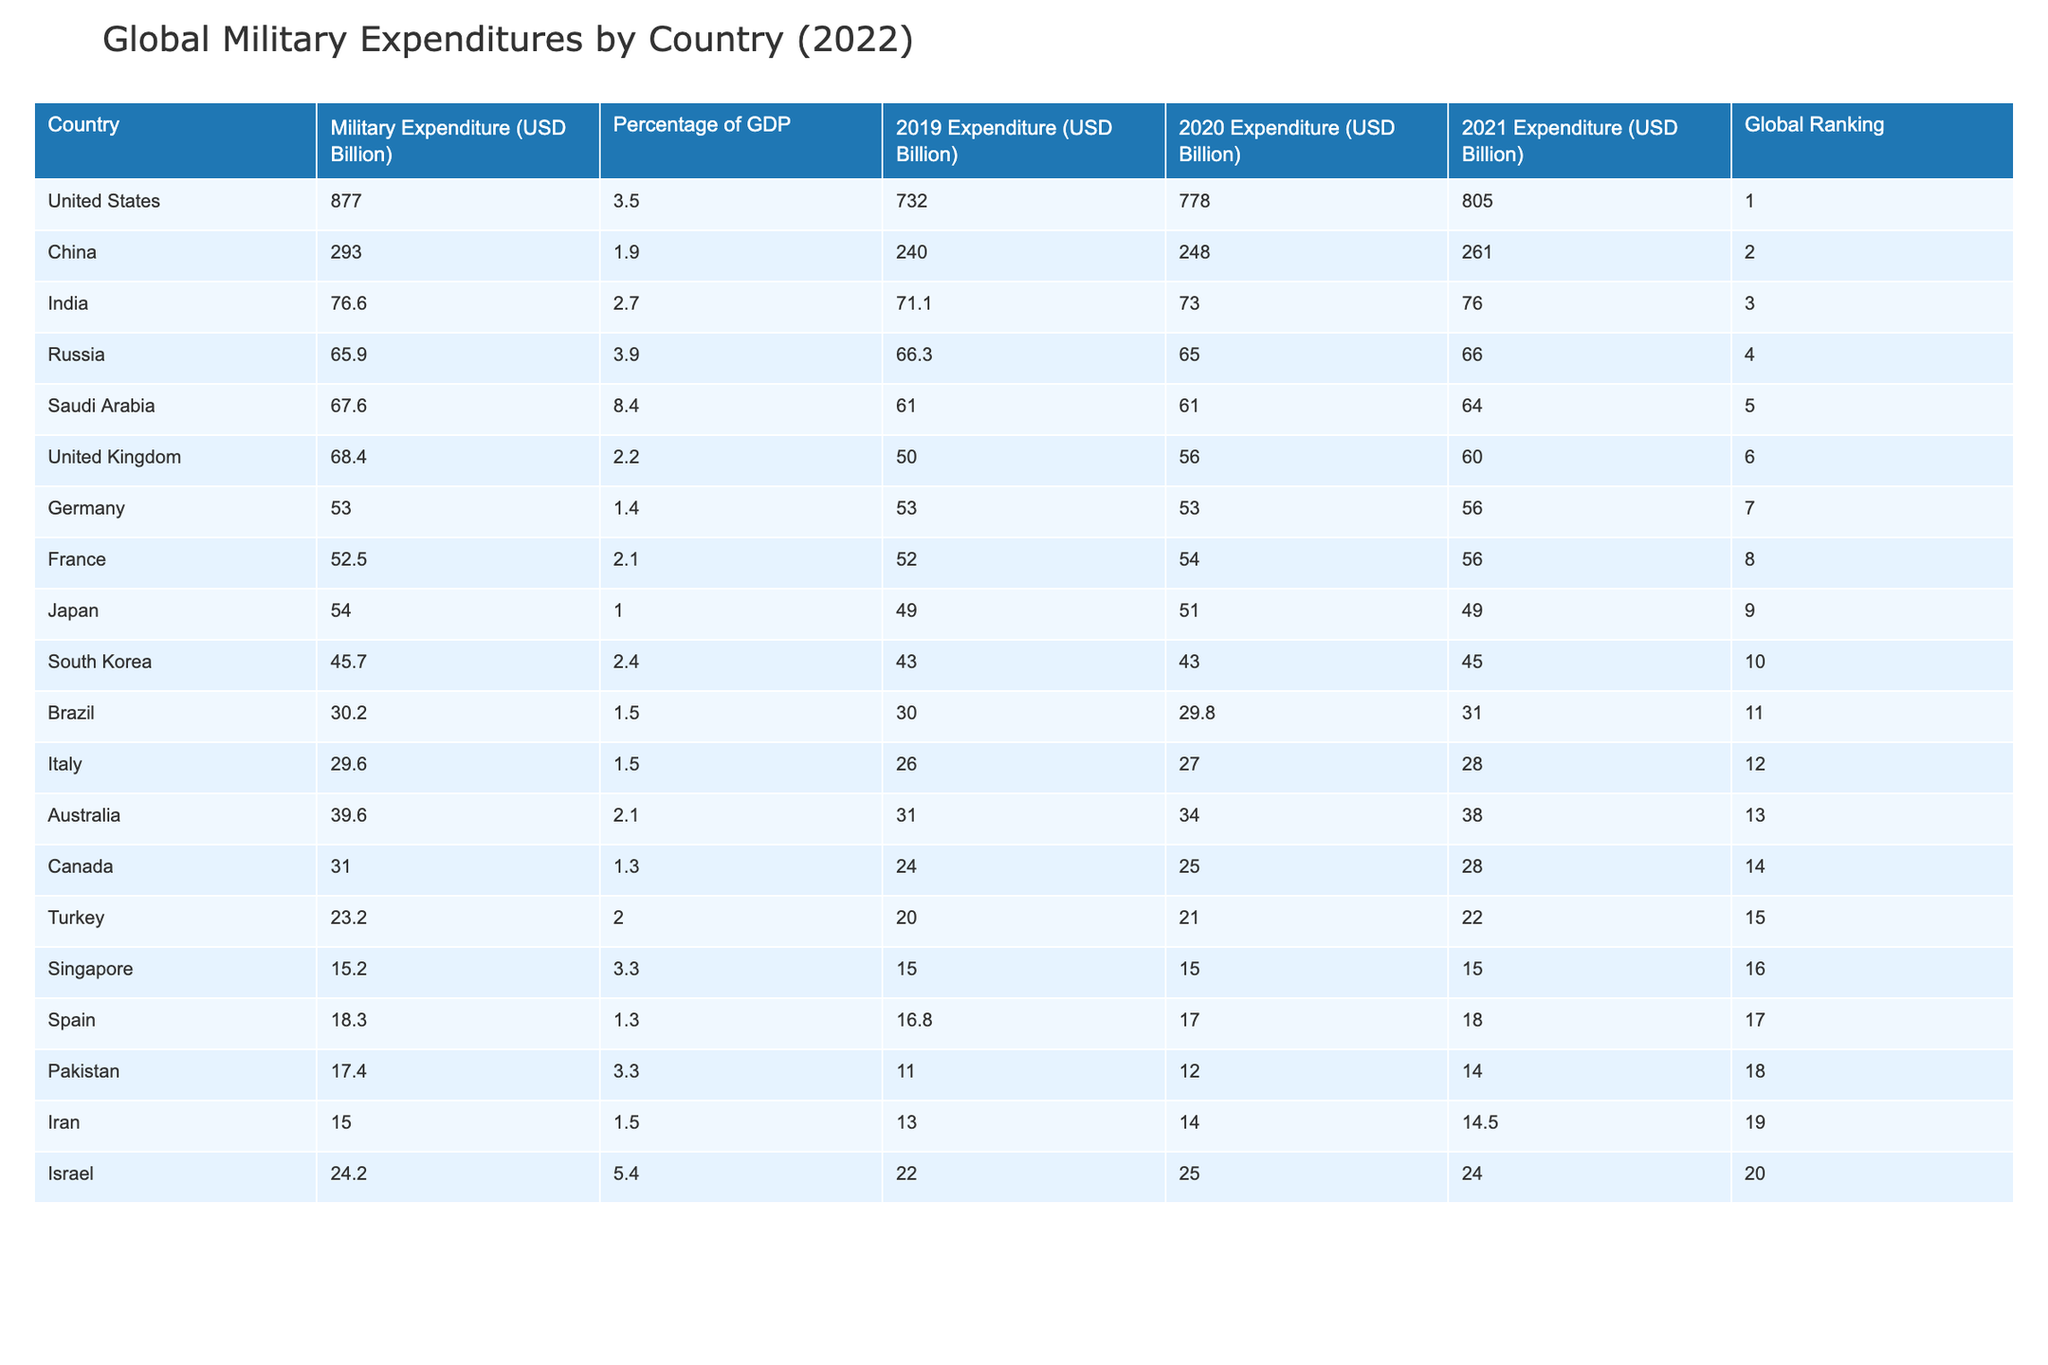What was the military expenditure of China in 2022? The table shows that China's military expenditure in 2022 was 293.0 billion USD, which is located in the column labeled 'Military Expenditure (USD Billion)' under the row for China.
Answer: 293.0 billion USD Which country spent the least on military expenditures in 2022? By comparing the military expenditures listed for each country, Pakistan has the lowest expenditure at 17.4 billion USD. This is found in the 'Military Expenditure (USD Billion)' column.
Answer: Pakistan What is the difference in military expenditure between the United States and India in 2022? The military expenditure for the United States is 877.0 billion USD and for India it is 76.6 billion USD. The difference is calculated as 877.0 - 76.6 = 800.4 billion USD.
Answer: 800.4 billion USD Is France's military expenditure higher than Japan's in 2022? France's military expenditure in 2022 is 52.5 billion USD while Japan's is 54.0 billion USD. By comparing these two values, it is clear that 52.5 is less than 54.0, therefore, the statement is false.
Answer: No What is the average military expenditure of the top 5 military spenders in 2022? The top 5 countries are the United States, China, India, Russia, and Saudi Arabia with expenditures of 877.0, 293.0, 76.6, 65.9, and 67.6 billion USD respectively. The total expenditure is 877.0 + 293.0 + 76.6 + 65.9 + 67.6 = 1380.1 billion USD. Dividing this by 5 gives an average of 1380.1 / 5 = 276.02 billion USD.
Answer: 276.02 billion USD Did any country spend more than 8% of their GDP on military expenditures in 2022? Referring to the 'Percentage of GDP' column, Saudi Arabia spent 8.4% of its GDP on military expenditures in 2022, which is greater than 8%. Therefore, the answer is yes.
Answer: Yes 